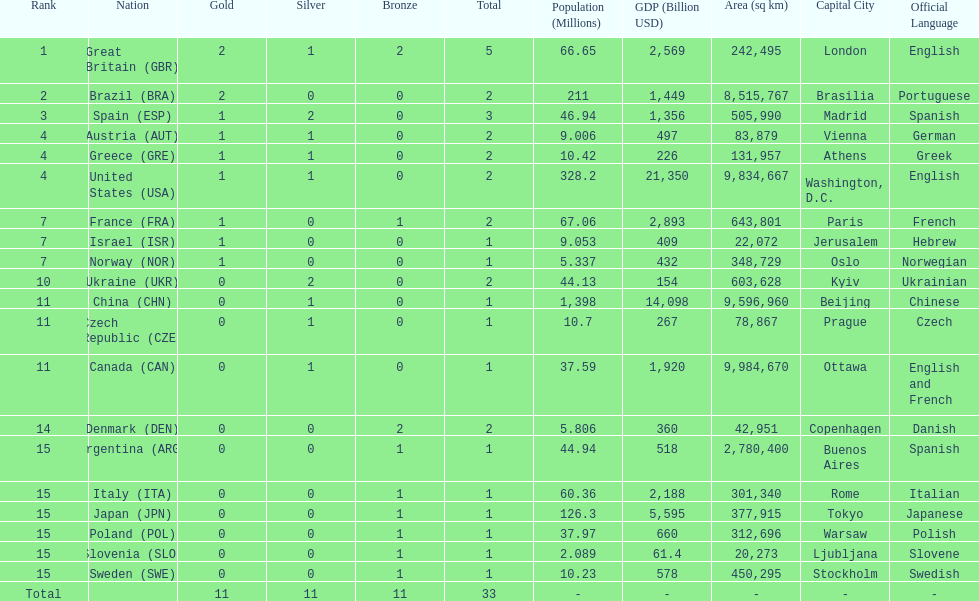Which nation was the only one to receive 3 medals? Spain (ESP). 